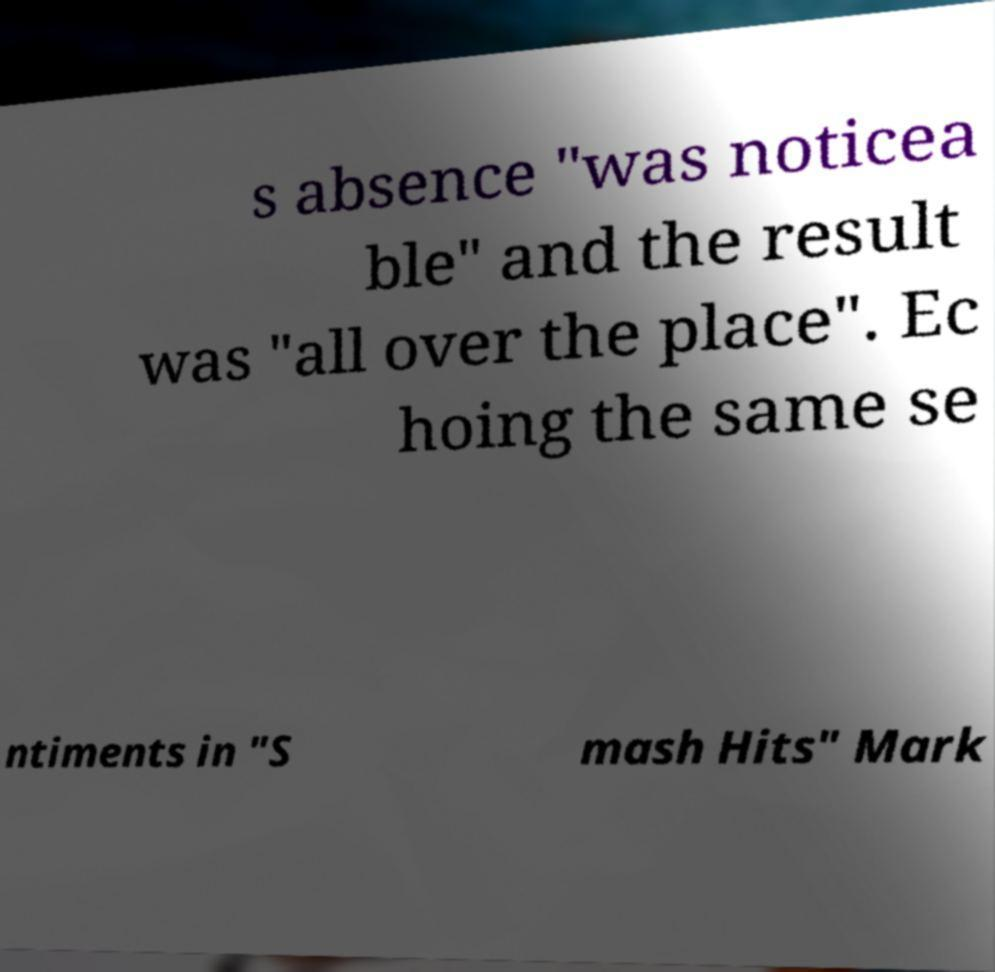There's text embedded in this image that I need extracted. Can you transcribe it verbatim? s absence "was noticea ble" and the result was "all over the place". Ec hoing the same se ntiments in "S mash Hits" Mark 